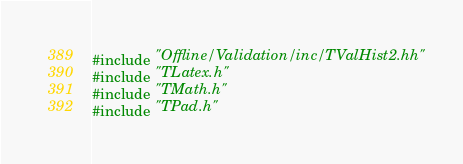Convert code to text. <code><loc_0><loc_0><loc_500><loc_500><_C++_>
#include "Offline/Validation/inc/TValHist2.hh"
#include "TLatex.h"
#include "TMath.h"
#include "TPad.h"</code> 